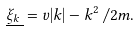Convert formula to latex. <formula><loc_0><loc_0><loc_500><loc_500>\underline { \xi _ { k } \, } = v | k | - k ^ { 2 } \, / 2 m .</formula> 